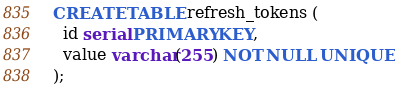Convert code to text. <code><loc_0><loc_0><loc_500><loc_500><_SQL_>CREATE TABLE refresh_tokens (
  id serial PRIMARY KEY,
  value varchar(255) NOT NULL UNIQUE
);
</code> 